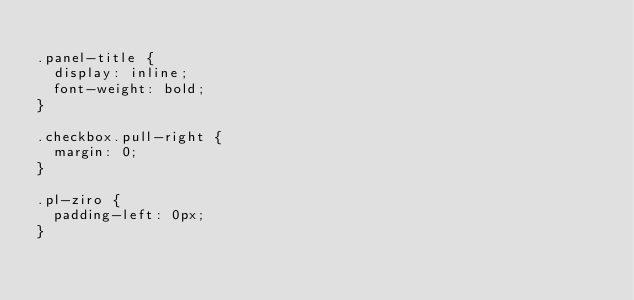Convert code to text. <code><loc_0><loc_0><loc_500><loc_500><_CSS_>
.panel-title {
	display: inline;
	font-weight: bold;
}

.checkbox.pull-right {
	margin: 0;
}

.pl-ziro {
	padding-left: 0px;
}</code> 